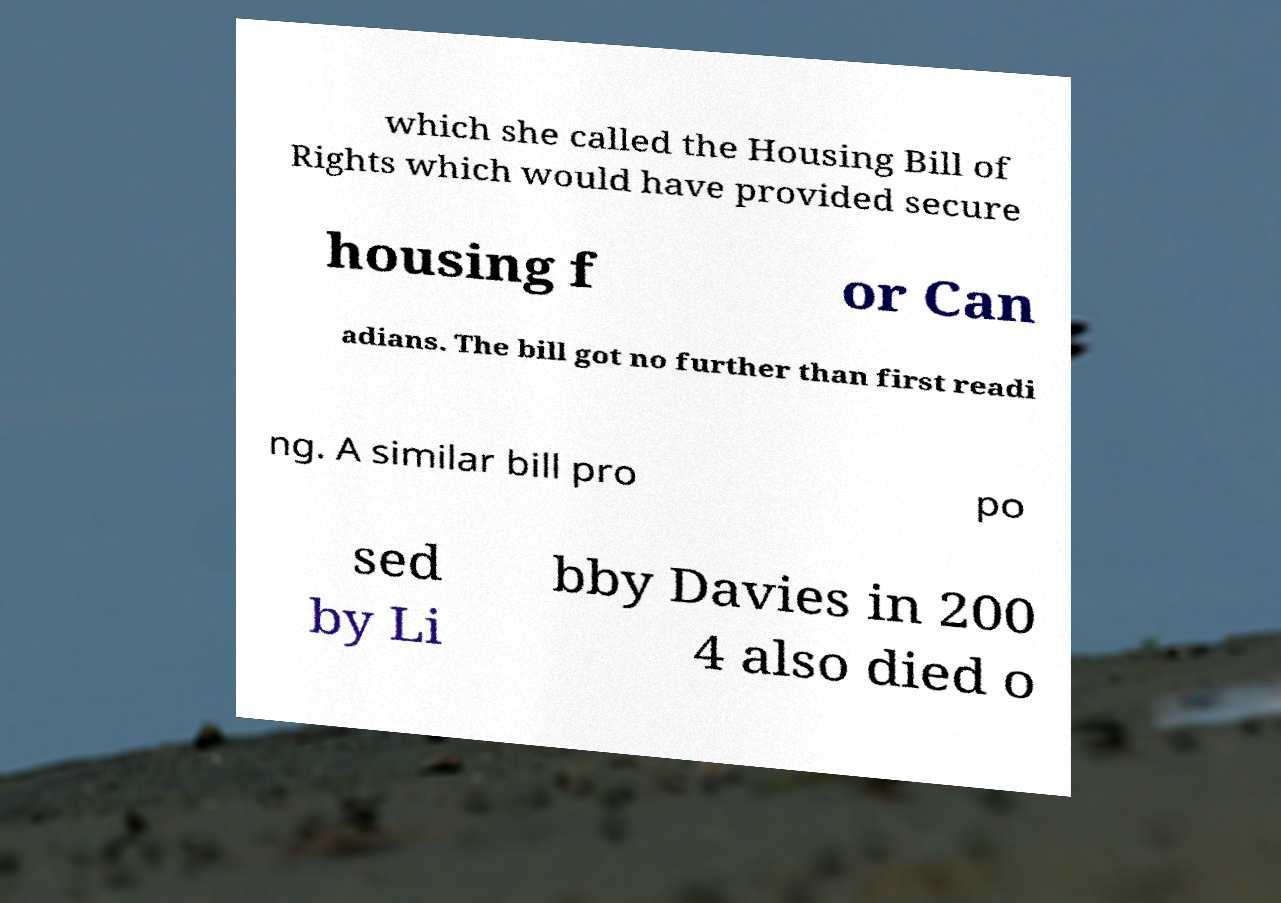Could you assist in decoding the text presented in this image and type it out clearly? which she called the Housing Bill of Rights which would have provided secure housing f or Can adians. The bill got no further than first readi ng. A similar bill pro po sed by Li bby Davies in 200 4 also died o 